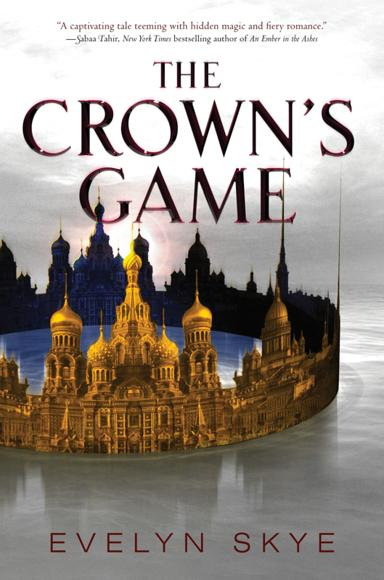What themes does the book cover, and can we see any thematic elements in this cover art? The book predominantly explores themes of rivalry and enchantment within a historical setting. Observing the cover art, the illustrious depiction of St. Petersburg’s skyline beneath a dusky sky beautifully foreshadows the mystical and competitive elements interwoven throughout the narrative. 